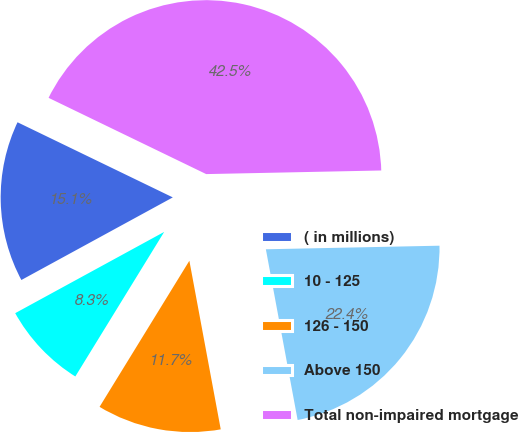Convert chart to OTSL. <chart><loc_0><loc_0><loc_500><loc_500><pie_chart><fcel>( in millions)<fcel>10 - 125<fcel>126 - 150<fcel>Above 150<fcel>Total non-impaired mortgage<nl><fcel>15.12%<fcel>8.28%<fcel>11.7%<fcel>22.4%<fcel>42.5%<nl></chart> 